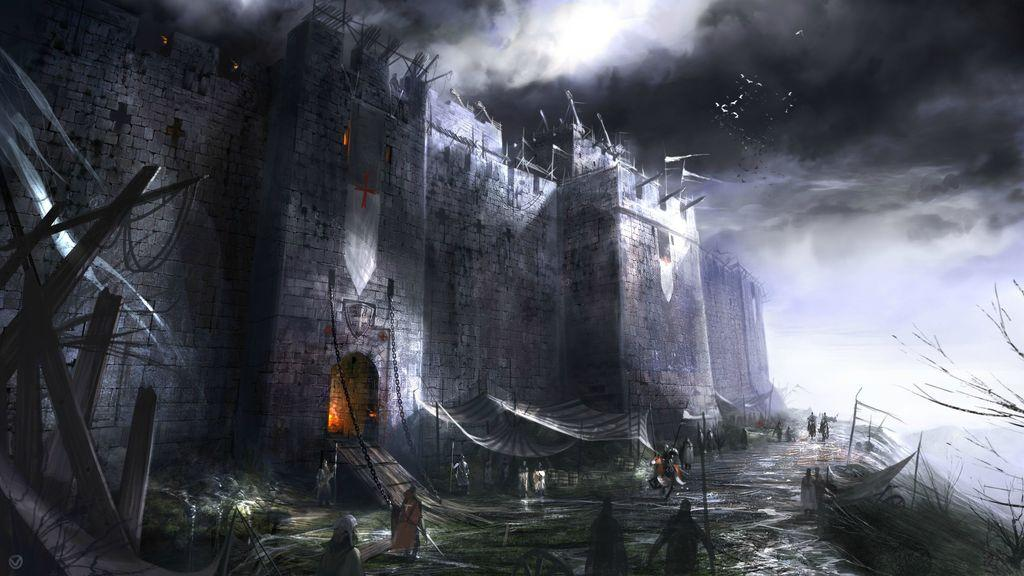What type of image is being described? The image appears to be an animation. What can be seen at the bottom of the image? There are people at the bottom of the image. What structure is located in the middle of the image? There is a fort in the middle of the image. What is visible at the top of the image? The sky is visible at the top of the image. What type of bed is visible in the image? There is no bed present in the image. What kind of lumber is being used to construct the fort in the image? The image is an animation, and it does not provide information about the materials used to construct the fort. 